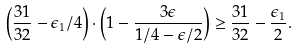<formula> <loc_0><loc_0><loc_500><loc_500>\left ( \frac { 3 1 } { 3 2 } - \epsilon _ { 1 } / 4 \right ) \cdot \left ( 1 - \frac { 3 \epsilon } { 1 / 4 - \epsilon / 2 } \right ) \geq \frac { 3 1 } { 3 2 } - \frac { \epsilon _ { 1 } } { 2 } .</formula> 